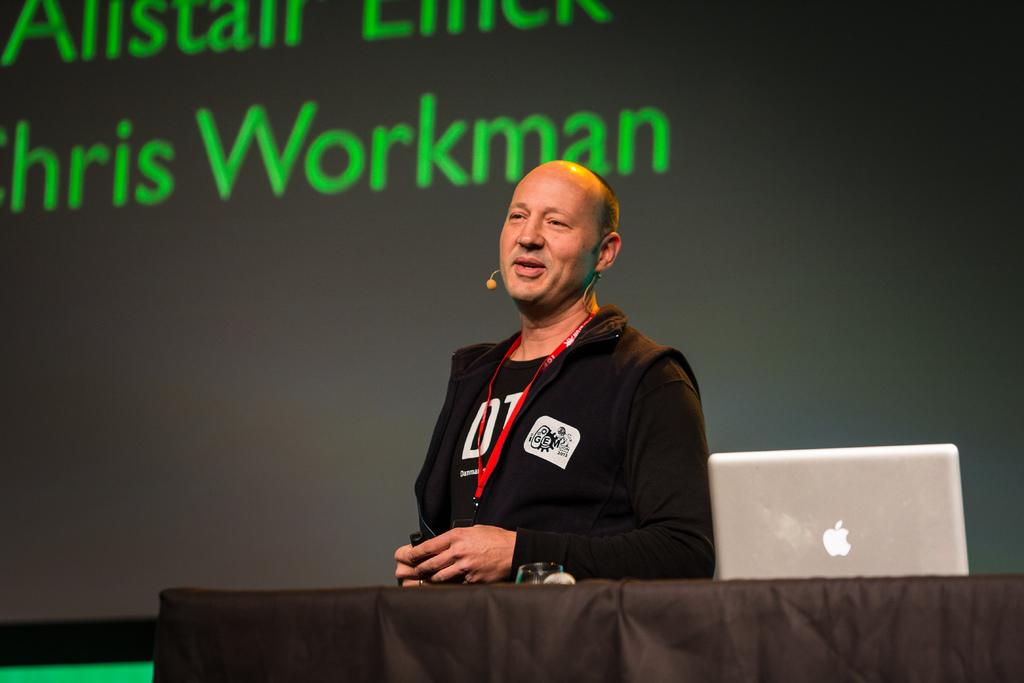What is the brand of the silver laptop?
Offer a very short reply. Answering does not require reading text in the image. What is chris's last name?
Provide a short and direct response. Workman. 